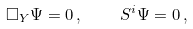Convert formula to latex. <formula><loc_0><loc_0><loc_500><loc_500>\Box _ { Y } \Psi = 0 \, , \quad S ^ { i } \Psi = 0 \, ,</formula> 